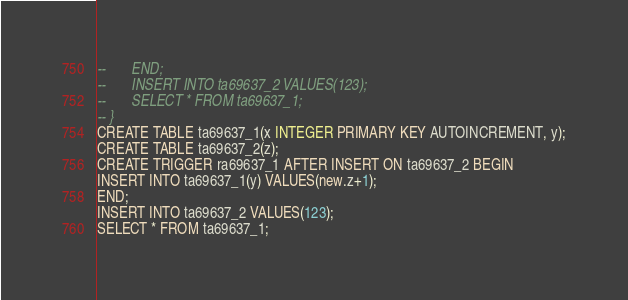<code> <loc_0><loc_0><loc_500><loc_500><_SQL_>--       END;
--       INSERT INTO ta69637_2 VALUES(123);
--       SELECT * FROM ta69637_1;
-- }
CREATE TABLE ta69637_1(x INTEGER PRIMARY KEY AUTOINCREMENT, y);
CREATE TABLE ta69637_2(z);
CREATE TRIGGER ra69637_1 AFTER INSERT ON ta69637_2 BEGIN
INSERT INTO ta69637_1(y) VALUES(new.z+1);
END;
INSERT INTO ta69637_2 VALUES(123);
SELECT * FROM ta69637_1;</code> 